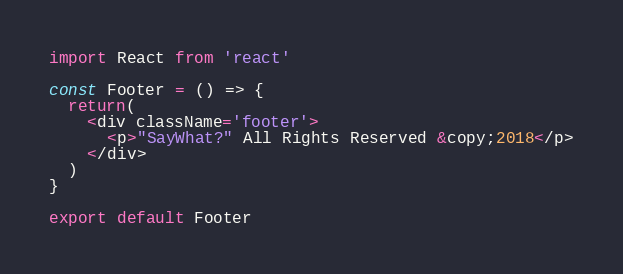Convert code to text. <code><loc_0><loc_0><loc_500><loc_500><_JavaScript_>import React from 'react'

const Footer = () => {
  return(
    <div className='footer'>
      <p>"SayWhat?" All Rights Reserved &copy;2018</p>
    </div>
  )
}

export default Footer</code> 